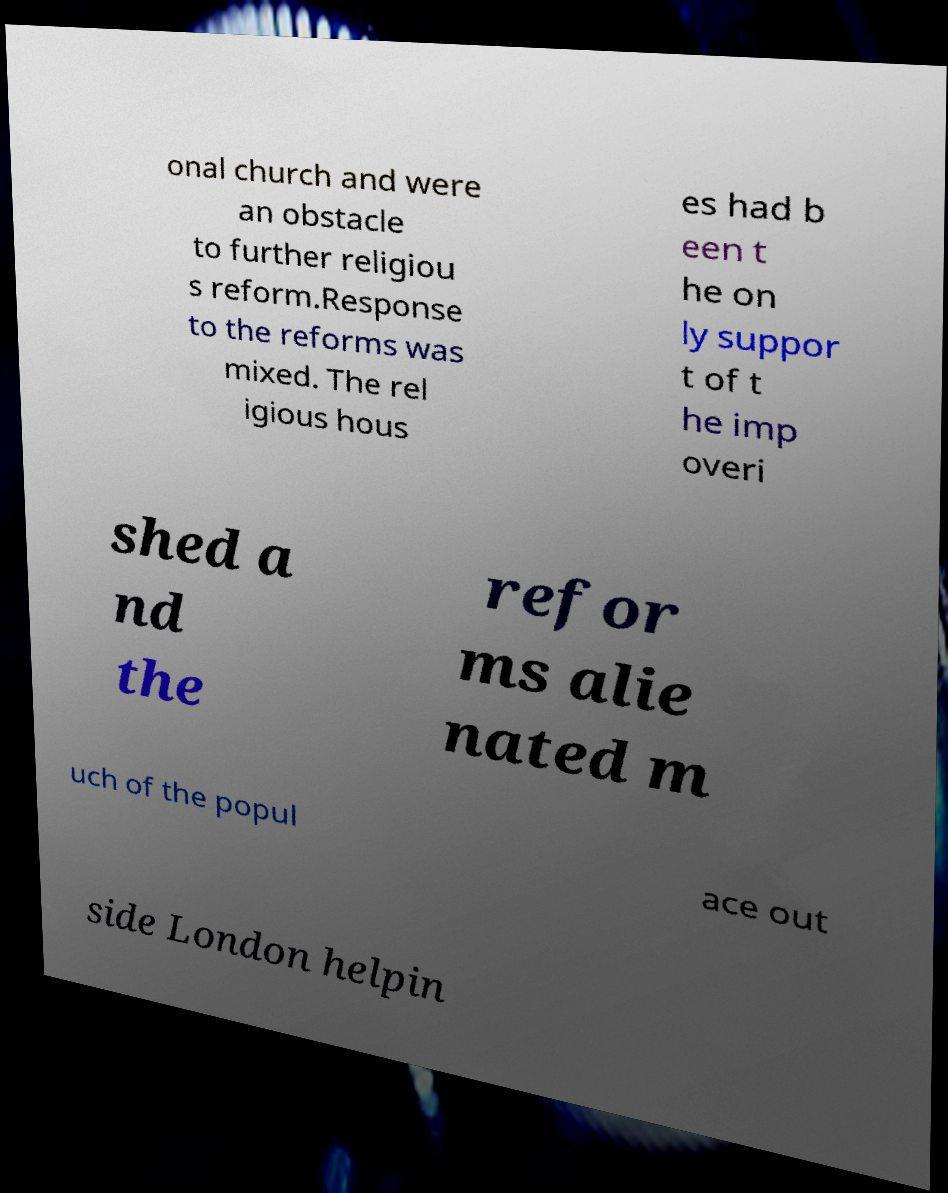Could you assist in decoding the text presented in this image and type it out clearly? onal church and were an obstacle to further religiou s reform.Response to the reforms was mixed. The rel igious hous es had b een t he on ly suppor t of t he imp overi shed a nd the refor ms alie nated m uch of the popul ace out side London helpin 